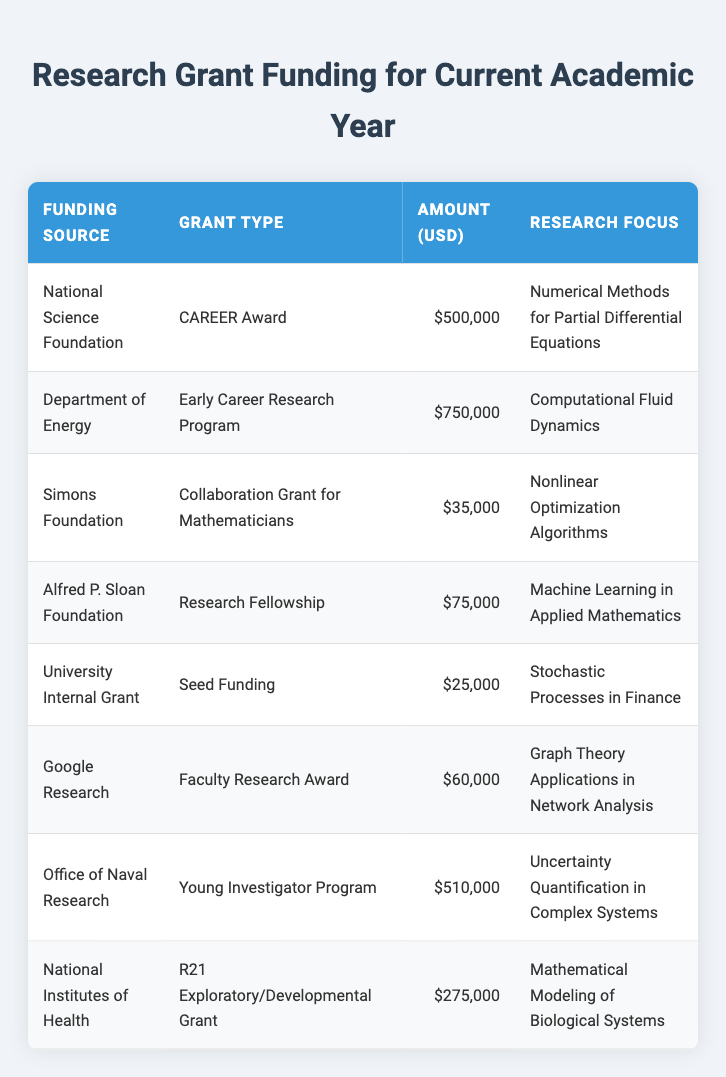What is the highest grant amount listed in the table? The table shows several grant amounts, including 500,000 from the National Science Foundation, and 750,000 from the Department of Energy. The highest amount presented is 750,000.
Answer: 750000 Which funding source provided the smallest grant amount? The data indicate that the University Internal Grant provided the smallest amount of 25,000. I checked each funding source and confirmed this is indeed the lowest value.
Answer: 25000 How much funding was awarded for Computational Fluid Dynamics? According to the table, the Department of Energy awarded 750,000 for this focus area, which can be found in the row corresponding to that funding source.
Answer: 750000 What is the total funding amount received from the National Institutes of Health and the Simons Foundation? The National Institutes of Health provided 275,000, and the Simons Foundation awarded 35,000. To find the total, add both amounts together: 275,000 + 35,000 = 310,000.
Answer: 310000 Is there any grant for research focused on Stochastic Processes in Finance? Yes, the University Internal Grant with a type of Seed Funding specifically supports research in Stochastic Processes in Finance, as indicated in the table.
Answer: Yes What is the average amount of funding provided for awards related to Uncertainty Quantification in Complex Systems and Numerical Methods for Partial Differential Equations? The funding amounts for these two focus areas are 510,000 (Office of Naval Research) and 500,000 (National Science Foundation), respectively. To find the average, sum these two: 510,000 + 500,000 = 1,010,000, then divide by 2 to get 505,000.
Answer: 505000 Which grant type received more than 100,000 in funding? The Department of Energy Early Career Research Program with 750,000, National Science Foundation CAREER Award with 500,000, and Office of Naval Research Young Investigator Program with 510,000 all exceed 100,000, confirming multiple types received more than this amount.
Answer: Yes What is the total amount of funding from private foundations (Simons Foundation and Alfred P. Sloan Foundation)? The Simons Foundation granted 35,000, and the Alfred P. Sloan Foundation awarded 75,000. The total for these two sources is 35,000 + 75,000 = 110,000.
Answer: 110000 Which funding source provided at least 500,000 for research? The Department of Energy (750,000), National Science Foundation (500,000), and Office of Naval Research (510,000) all provided at least 500,000 in funding, as shown in respective rows of the table.
Answer: Yes 